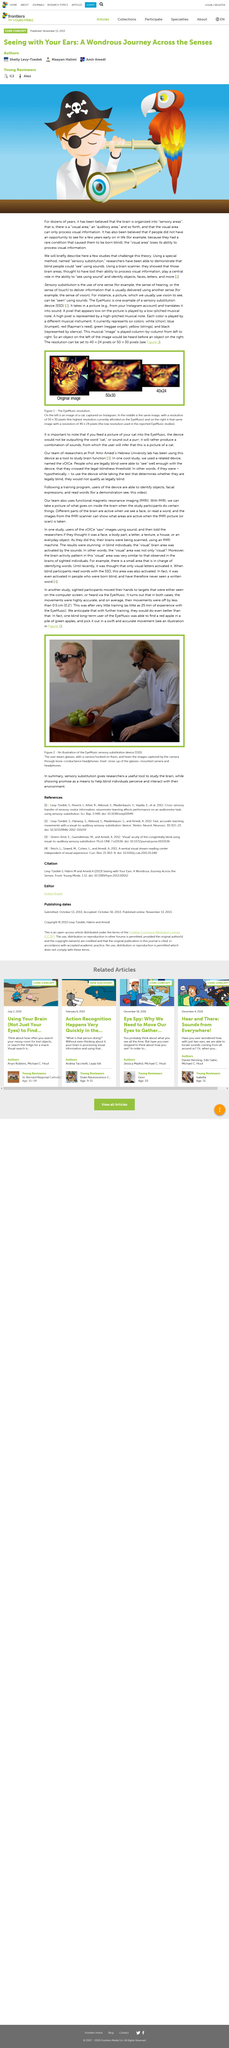List a handful of essential elements in this visual. Researchers have been able to demonstrate that blind people can use sounds to see by using a special method. For dozens of years, it was believed that the brain was organized into sensory areas. The brain scanner was used to demonstrate the areas of the brain that were believed to have lost their function as the central focus of the study. 